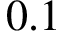<formula> <loc_0><loc_0><loc_500><loc_500>0 . 1</formula> 